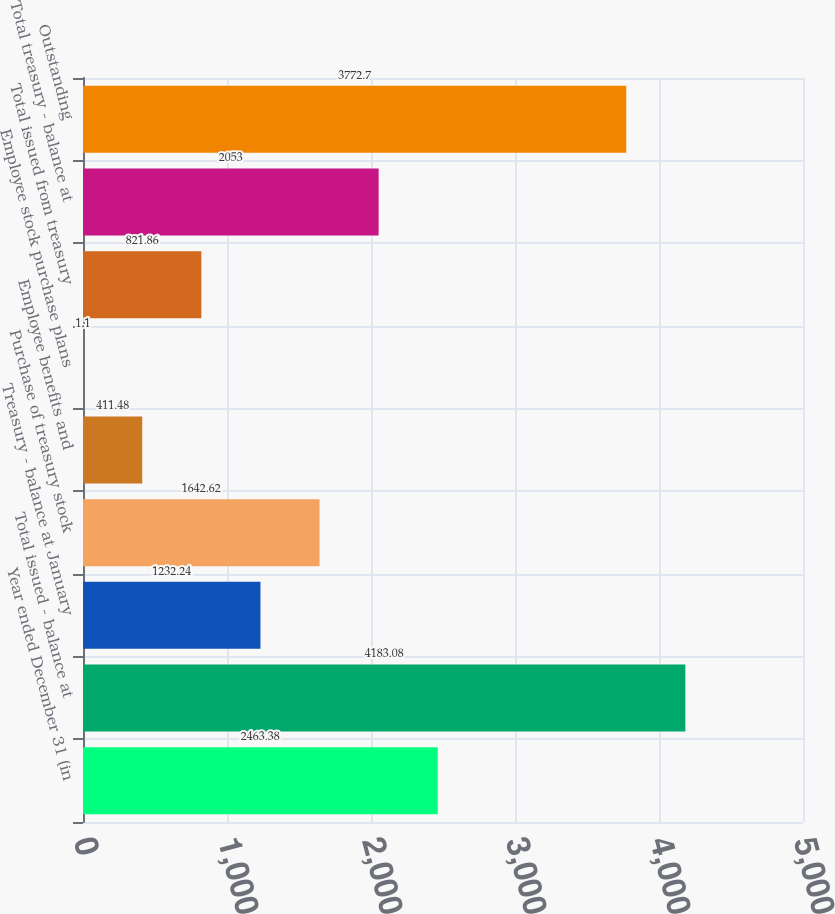<chart> <loc_0><loc_0><loc_500><loc_500><bar_chart><fcel>Year ended December 31 (in<fcel>Total issued - balance at<fcel>Treasury - balance at January<fcel>Purchase of treasury stock<fcel>Employee benefits and<fcel>Employee stock purchase plans<fcel>Total issued from treasury<fcel>Total treasury - balance at<fcel>Outstanding<nl><fcel>2463.38<fcel>4183.08<fcel>1232.24<fcel>1642.62<fcel>411.48<fcel>1.1<fcel>821.86<fcel>2053<fcel>3772.7<nl></chart> 